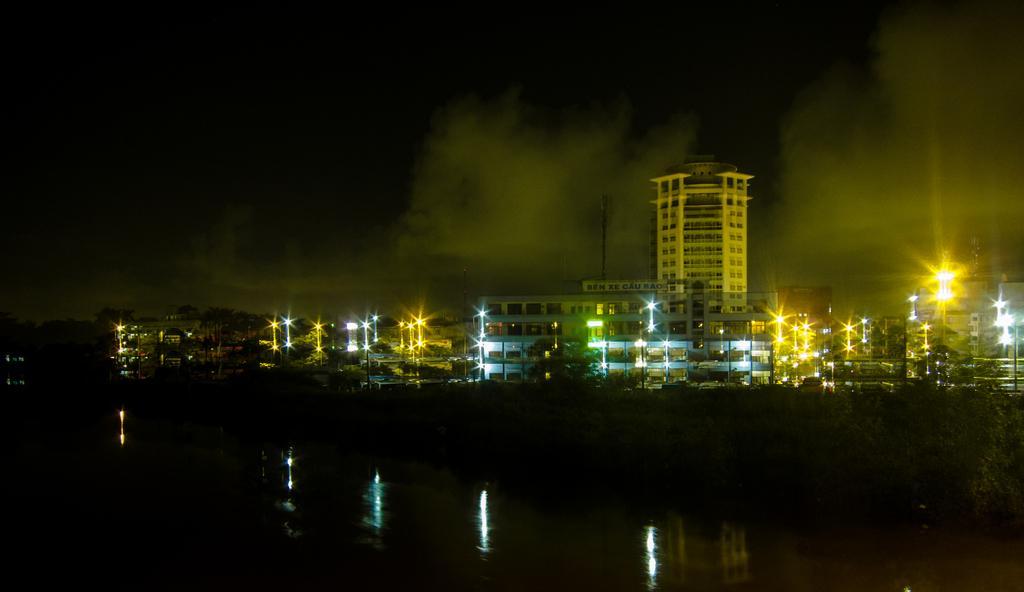How would you summarize this image in a sentence or two? In this image there is water in the background there buildings and lights. 